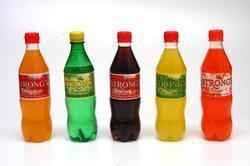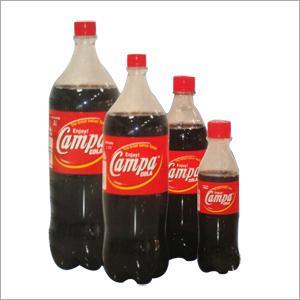The first image is the image on the left, the second image is the image on the right. Evaluate the accuracy of this statement regarding the images: "One image shows five upright identical bottles arranged in a V-formation.". Is it true? Answer yes or no. No. 